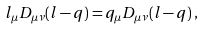Convert formula to latex. <formula><loc_0><loc_0><loc_500><loc_500>l _ { \mu } D _ { \mu \nu } ( l - q ) = q _ { \mu } D _ { \mu \nu } ( l - q ) \, ,</formula> 